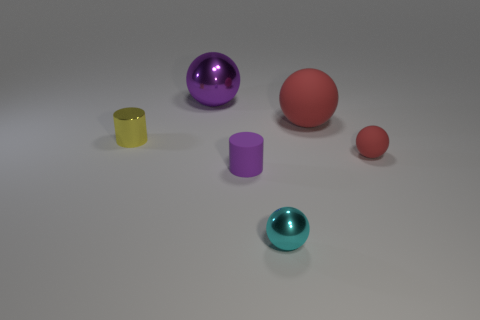What can you infer about the material properties of the objects? From the image, it is possible to infer that the objects possess different material properties. The spheres and the cylinders exhibit varying degrees of shininess and translucency, indicating that they are likely made from various materials such as rubber, plastic, or glass. The distinctions in textures and light reflections suggest that some objects are matte and rubbery, while others are glossy and possibly hard. 